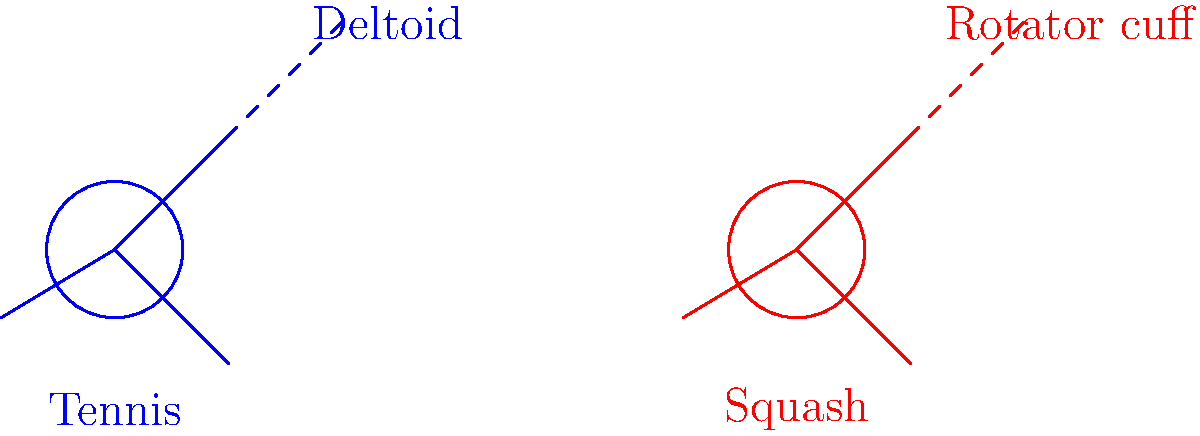Based on the anatomical diagram, which muscle group is likely to experience higher activation during a squash forehand compared to a tennis forehand, and why might this be surprising to a professional tennis player? 1. Analyze the diagram:
   - The blue figure represents a tennis player, and the red figure represents a squash player.
   - The dashed lines indicate muscle activation patterns for each sport.

2. Compare muscle activation:
   - For tennis, the deltoid muscle is highlighted.
   - For squash, the rotator cuff muscles are highlighted.

3. Understand the differences:
   - Tennis forehand typically involves a larger, more open swing with more shoulder rotation.
   - Squash forehand often requires a shorter, more compact swing due to court constraints.

4. Consider the rotator cuff's role:
   - The rotator cuff muscles stabilize the shoulder joint.
   - They are crucial for quick, powerful movements in confined spaces.

5. Relate to the persona:
   - A professional tennis player might underestimate the intensity of squash.
   - They may assume their shoulder muscles are equally or more developed for all racquet sports.

6. Explain the surprise factor:
   - The higher activation of rotator cuff muscles in squash might be unexpected.
   - It demonstrates the sport's unique demands on shoulder stability and control.

7. Conclude:
   - The rotator cuff muscles likely experience higher activation during a squash forehand.
   - This challenges the assumption that tennis requires more shoulder muscle engagement.
Answer: Rotator cuff muscles; unexpected intensity and shoulder stability demands in squash. 